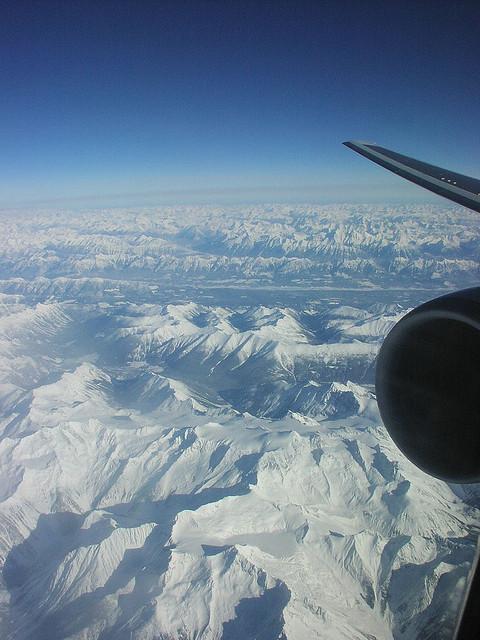Are there any clouds visible?
Write a very short answer. No. Does this appear to have been taken from the window of a plane?
Concise answer only. Yes. How high in the air is this picture taken?
Keep it brief. 1,000 feet. What covers the ground?
Concise answer only. Snow. 